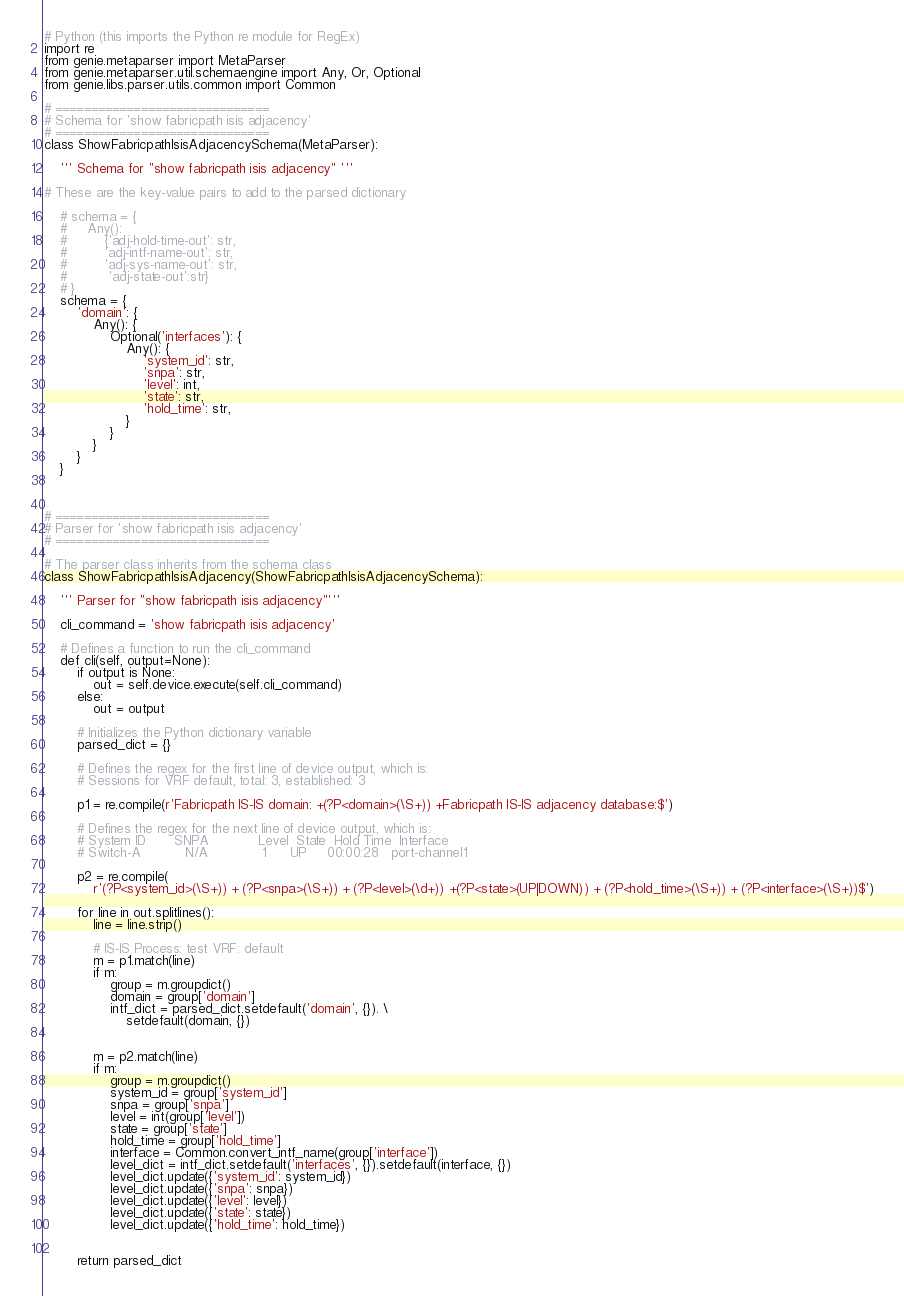Convert code to text. <code><loc_0><loc_0><loc_500><loc_500><_Python_># Python (this imports the Python re module for RegEx)
import re
from genie.metaparser import MetaParser
from genie.metaparser.util.schemaengine import Any, Or, Optional
from genie.libs.parser.utils.common import Common

# ==============================
# Schema for 'show fabricpath isis adjacency'
# ==============================
class ShowFabricpathIsisAdjacencySchema(MetaParser):

    ''' Schema for "show fabricpath isis adjacency" '''

# These are the key-value pairs to add to the parsed dictionary

    # schema = {
    #     Any():
    #         {'adj-hold-time-out': str,
    #         'adj-intf-name-out': str,
    #         'adj-sys-name-out': str,
    #          'adj-state-out':str}
    # }
    schema = {
        'domain': {
            Any(): {
                Optional('interfaces'): {
                    Any(): {
                        'system_id': str,
                        'snpa': str,
                        'level': int,
                        'state': str,
                        'hold_time': str,
                    }
                }
            }
        }
    }



# ==============================
# Parser for 'show fabricpath isis adjacency'
# ==============================

# The parser class inherits from the schema class
class ShowFabricpathIsisAdjacency(ShowFabricpathIsisAdjacencySchema):

    ''' Parser for "show fabricpath isis adjacency"'''

    cli_command = 'show fabricpath isis adjacency'

    # Defines a function to run the cli_command
    def cli(self, output=None):
        if output is None:
            out = self.device.execute(self.cli_command)
        else:
            out = output

        # Initializes the Python dictionary variable
        parsed_dict = {}

        # Defines the regex for the first line of device output, which is:
        # Sessions for VRF default, total: 3, established: 3

        p1 = re.compile(r'Fabricpath IS-IS domain: +(?P<domain>(\S+)) +Fabricpath IS-IS adjacency database:$')

        # Defines the regex for the next line of device output, which is:
        # System ID       SNPA            Level  State  Hold Time  Interface
        # Switch-A           N/A             1      UP     00:00:28   port-channel1

        p2 = re.compile(
            r'(?P<system_id>(\S+)) + (?P<snpa>(\S+)) + (?P<level>(\d+)) +(?P<state>(UP|DOWN)) + (?P<hold_time>(\S+)) + (?P<interface>(\S+))$')

        for line in out.splitlines():
            line = line.strip()

            # IS-IS Process: test VRF: default
            m = p1.match(line)
            if m:
                group = m.groupdict()
                domain = group['domain']
                intf_dict = parsed_dict.setdefault('domain', {}). \
                    setdefault(domain, {})


            m = p2.match(line)
            if m:
                group = m.groupdict()
                system_id = group['system_id']
                snpa = group['snpa']
                level = int(group['level'])
                state = group['state']
                hold_time = group['hold_time']
                interface = Common.convert_intf_name(group['interface'])
                level_dict = intf_dict.setdefault('interfaces', {}).setdefault(interface, {})
                level_dict.update({'system_id': system_id})
                level_dict.update({'snpa': snpa})
                level_dict.update({'level': level})
                level_dict.update({'state': state})
                level_dict.update({'hold_time': hold_time})


        return parsed_dict</code> 